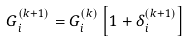Convert formula to latex. <formula><loc_0><loc_0><loc_500><loc_500>G _ { i } ^ { ( k + 1 ) } = G _ { i } ^ { ( k ) } \left [ 1 + \delta _ { i } ^ { ( k + 1 ) } \right ]</formula> 